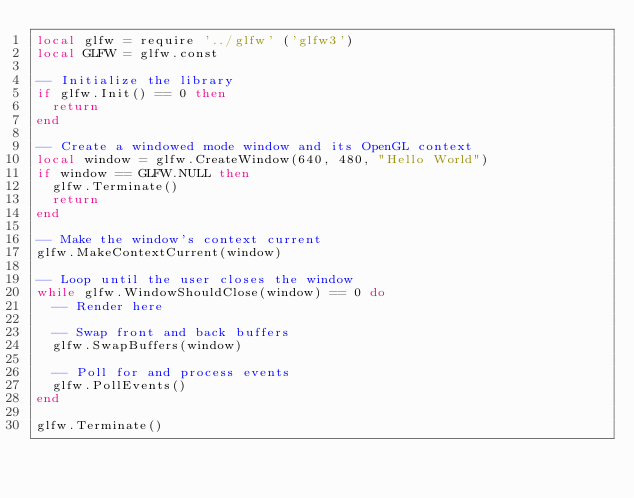Convert code to text. <code><loc_0><loc_0><loc_500><loc_500><_Lua_>local glfw = require '../glfw' ('glfw3')
local GLFW = glfw.const

-- Initialize the library
if glfw.Init() == 0 then
  return
end

-- Create a windowed mode window and its OpenGL context
local window = glfw.CreateWindow(640, 480, "Hello World")
if window == GLFW.NULL then
  glfw.Terminate()
  return
end

-- Make the window's context current
glfw.MakeContextCurrent(window)

-- Loop until the user closes the window
while glfw.WindowShouldClose(window) == 0 do
  -- Render here

  -- Swap front and back buffers
  glfw.SwapBuffers(window)

  -- Poll for and process events
  glfw.PollEvents()
end

glfw.Terminate()
</code> 